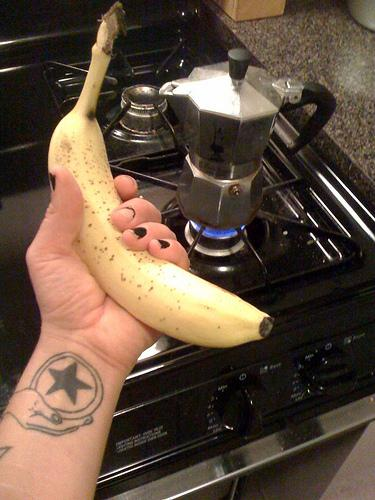Question: what is in the person's hand?
Choices:
A. A Trumpet.
B. A banana.
C. A Telephone.
D. A Pillow.
Answer with the letter. Answer: B Question: what color is the stove top?
Choices:
A. White.
B. Yellow.
C. Black.
D. Gray.
Answer with the letter. Answer: C 